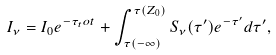Convert formula to latex. <formula><loc_0><loc_0><loc_500><loc_500>I _ { \nu } = I _ { 0 } e ^ { - \tau _ { t } o t } + \int ^ { \tau ( Z _ { 0 } ) } _ { \tau ( - \infty ) } { S _ { \nu } ( \tau ^ { \prime } ) e ^ { - \tau ^ { \prime } } d \tau ^ { \prime } } ,</formula> 